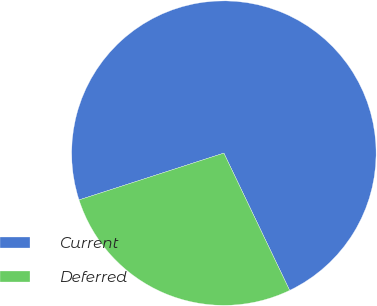Convert chart to OTSL. <chart><loc_0><loc_0><loc_500><loc_500><pie_chart><fcel>Current<fcel>Deferred<nl><fcel>72.86%<fcel>27.14%<nl></chart> 